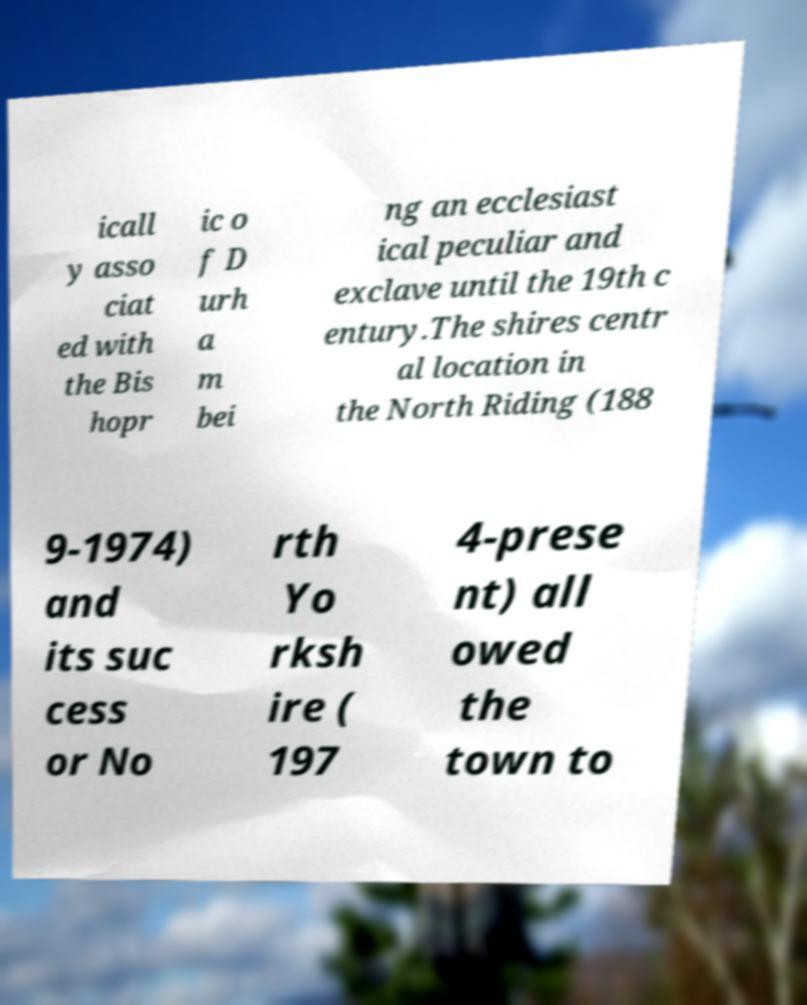Please identify and transcribe the text found in this image. icall y asso ciat ed with the Bis hopr ic o f D urh a m bei ng an ecclesiast ical peculiar and exclave until the 19th c entury.The shires centr al location in the North Riding (188 9-1974) and its suc cess or No rth Yo rksh ire ( 197 4-prese nt) all owed the town to 